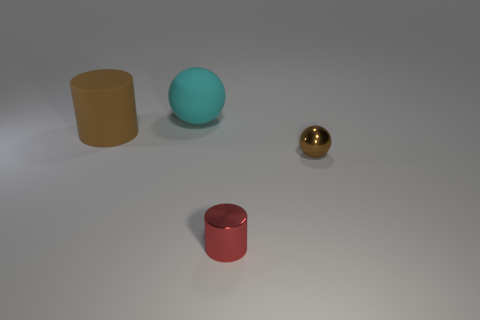What material is the small red thing?
Give a very brief answer. Metal. What size is the thing that is the same color as the rubber cylinder?
Offer a very short reply. Small. Do the tiny brown metal object and the big thing that is right of the brown matte thing have the same shape?
Keep it short and to the point. Yes. What material is the small thing to the left of the sphere that is in front of the large object on the right side of the big matte cylinder?
Your answer should be very brief. Metal. How many big red metallic things are there?
Provide a short and direct response. 0. What number of blue things are tiny objects or rubber things?
Give a very brief answer. 0. How many other things are the same shape as the large brown rubber thing?
Your response must be concise. 1. Does the cylinder behind the metal sphere have the same color as the tiny thing that is behind the small shiny cylinder?
Ensure brevity in your answer.  Yes. What number of small things are matte cylinders or cyan balls?
Offer a very short reply. 0. There is another thing that is the same shape as the small red metallic object; what is its size?
Your answer should be very brief. Large. 